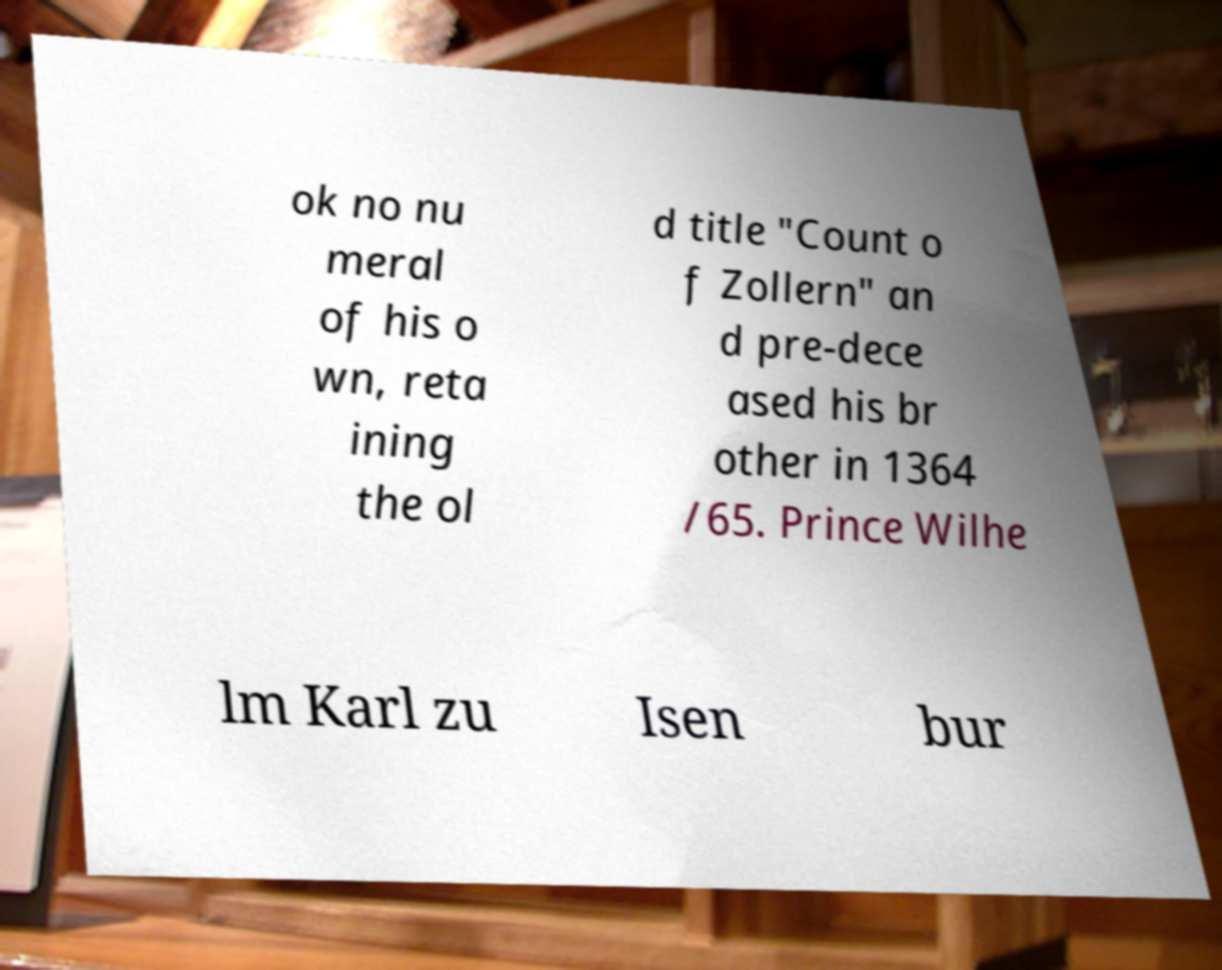Please read and relay the text visible in this image. What does it say? ok no nu meral of his o wn, reta ining the ol d title "Count o f Zollern" an d pre-dece ased his br other in 1364 /65. Prince Wilhe lm Karl zu Isen bur 